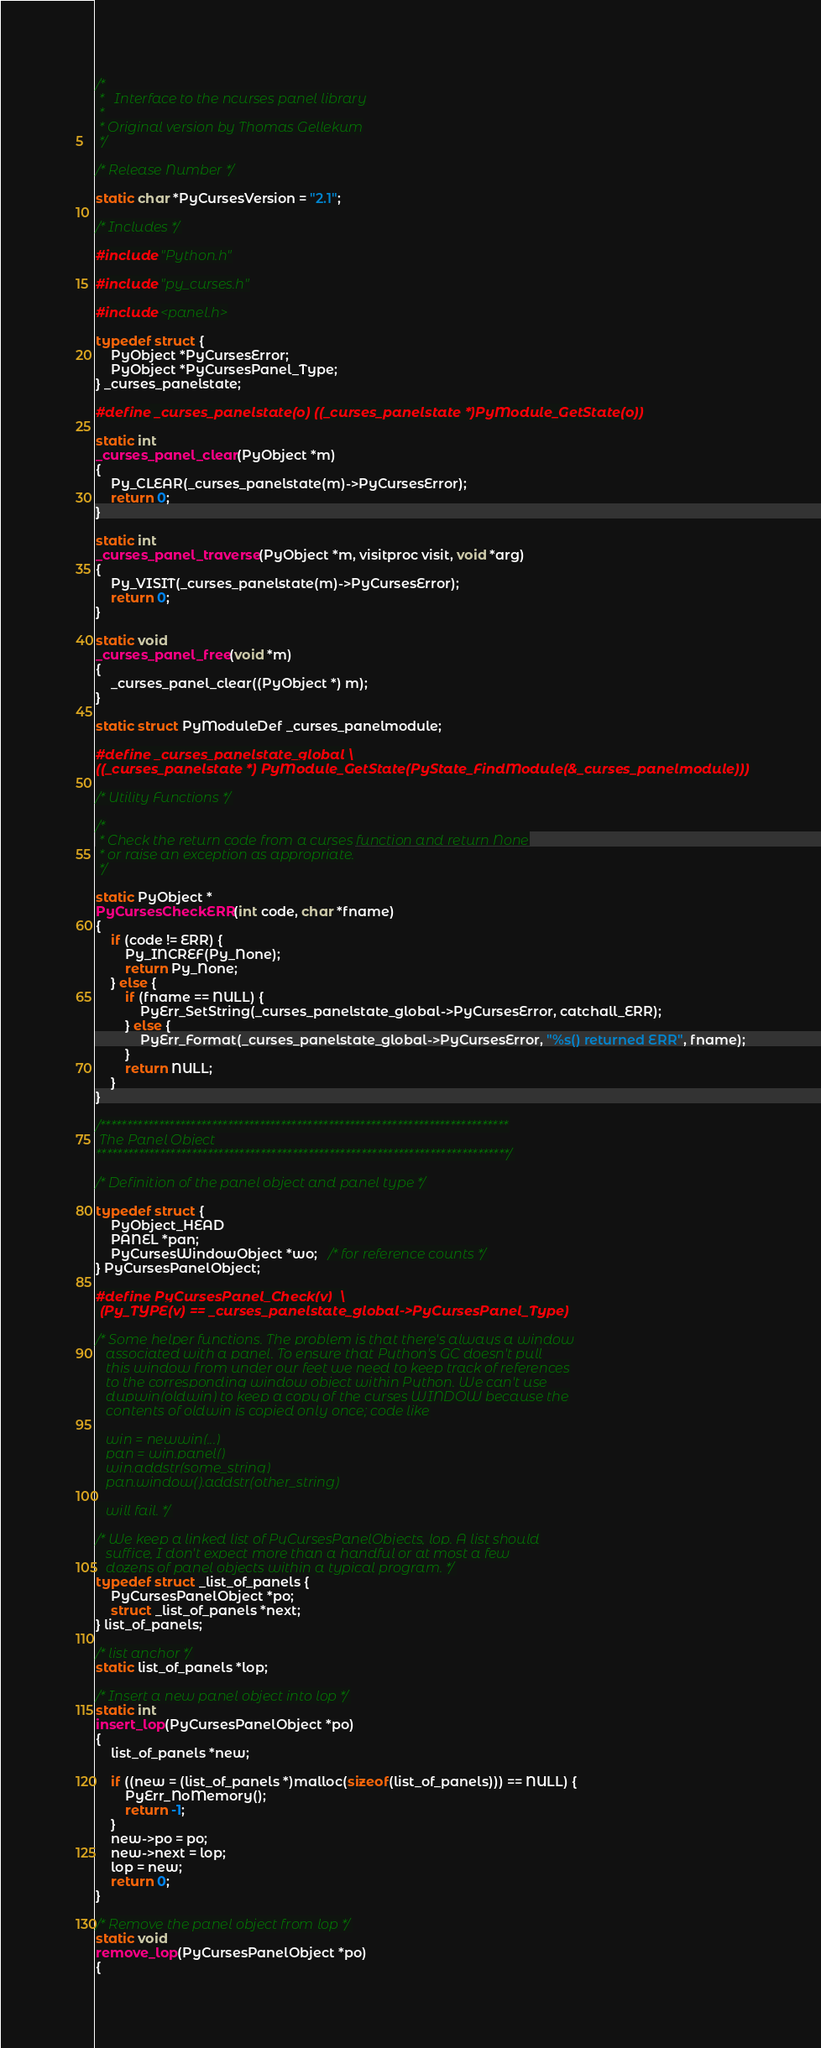Convert code to text. <code><loc_0><loc_0><loc_500><loc_500><_C_>/*
 *   Interface to the ncurses panel library
 *
 * Original version by Thomas Gellekum
 */

/* Release Number */

static char *PyCursesVersion = "2.1";

/* Includes */

#include "Python.h"

#include "py_curses.h"

#include <panel.h>

typedef struct {
    PyObject *PyCursesError;
    PyObject *PyCursesPanel_Type;
} _curses_panelstate;

#define _curses_panelstate(o) ((_curses_panelstate *)PyModule_GetState(o))

static int
_curses_panel_clear(PyObject *m)
{
    Py_CLEAR(_curses_panelstate(m)->PyCursesError);
    return 0;
}

static int
_curses_panel_traverse(PyObject *m, visitproc visit, void *arg)
{
    Py_VISIT(_curses_panelstate(m)->PyCursesError);
    return 0;
}

static void
_curses_panel_free(void *m)
{
    _curses_panel_clear((PyObject *) m);
}

static struct PyModuleDef _curses_panelmodule;

#define _curses_panelstate_global \
((_curses_panelstate *) PyModule_GetState(PyState_FindModule(&_curses_panelmodule)))

/* Utility Functions */

/*
 * Check the return code from a curses function and return None
 * or raise an exception as appropriate.
 */

static PyObject *
PyCursesCheckERR(int code, char *fname)
{
    if (code != ERR) {
        Py_INCREF(Py_None);
        return Py_None;
    } else {
        if (fname == NULL) {
            PyErr_SetString(_curses_panelstate_global->PyCursesError, catchall_ERR);
        } else {
            PyErr_Format(_curses_panelstate_global->PyCursesError, "%s() returned ERR", fname);
        }
        return NULL;
    }
}

/*****************************************************************************
 The Panel Object
******************************************************************************/

/* Definition of the panel object and panel type */

typedef struct {
    PyObject_HEAD
    PANEL *pan;
    PyCursesWindowObject *wo;   /* for reference counts */
} PyCursesPanelObject;

#define PyCursesPanel_Check(v)  \
 (Py_TYPE(v) == _curses_panelstate_global->PyCursesPanel_Type)

/* Some helper functions. The problem is that there's always a window
   associated with a panel. To ensure that Python's GC doesn't pull
   this window from under our feet we need to keep track of references
   to the corresponding window object within Python. We can't use
   dupwin(oldwin) to keep a copy of the curses WINDOW because the
   contents of oldwin is copied only once; code like

   win = newwin(...)
   pan = win.panel()
   win.addstr(some_string)
   pan.window().addstr(other_string)

   will fail. */

/* We keep a linked list of PyCursesPanelObjects, lop. A list should
   suffice, I don't expect more than a handful or at most a few
   dozens of panel objects within a typical program. */
typedef struct _list_of_panels {
    PyCursesPanelObject *po;
    struct _list_of_panels *next;
} list_of_panels;

/* list anchor */
static list_of_panels *lop;

/* Insert a new panel object into lop */
static int
insert_lop(PyCursesPanelObject *po)
{
    list_of_panels *new;

    if ((new = (list_of_panels *)malloc(sizeof(list_of_panels))) == NULL) {
        PyErr_NoMemory();
        return -1;
    }
    new->po = po;
    new->next = lop;
    lop = new;
    return 0;
}

/* Remove the panel object from lop */
static void
remove_lop(PyCursesPanelObject *po)
{</code> 